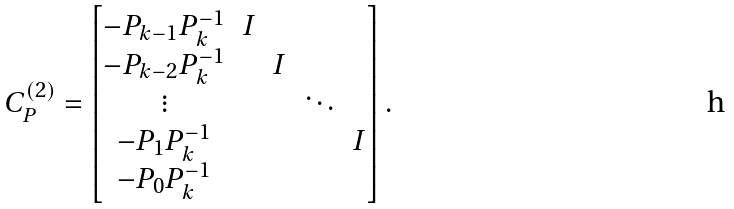Convert formula to latex. <formula><loc_0><loc_0><loc_500><loc_500>C _ { P } ^ { ( 2 ) } = \begin{bmatrix} - P _ { k - 1 } P _ { k } ^ { - 1 } & I & & & \\ - P _ { k - 2 } P _ { k } ^ { - 1 } & & I & & \\ \vdots & & & \ddots & \\ - P _ { 1 } P _ { k } ^ { - 1 } & & & & I \\ - P _ { 0 } P _ { k } ^ { - 1 } & & & & \end{bmatrix} .</formula> 